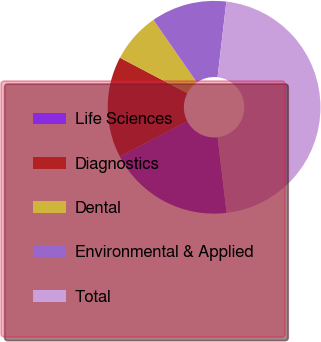<chart> <loc_0><loc_0><loc_500><loc_500><pie_chart><fcel>Life Sciences<fcel>Diagnostics<fcel>Dental<fcel>Environmental & Applied<fcel>Total<nl><fcel>19.23%<fcel>15.36%<fcel>7.63%<fcel>11.5%<fcel>46.28%<nl></chart> 